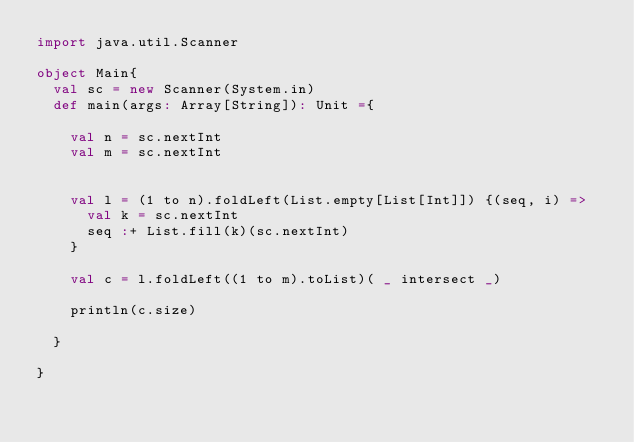<code> <loc_0><loc_0><loc_500><loc_500><_Scala_>import java.util.Scanner

object Main{
  val sc = new Scanner(System.in)
  def main(args: Array[String]): Unit ={

    val n = sc.nextInt
    val m = sc.nextInt


    val l = (1 to n).foldLeft(List.empty[List[Int]]) {(seq, i) =>
      val k = sc.nextInt
      seq :+ List.fill(k)(sc.nextInt)
    }

    val c = l.foldLeft((1 to m).toList)( _ intersect _)

    println(c.size)

  }

}</code> 